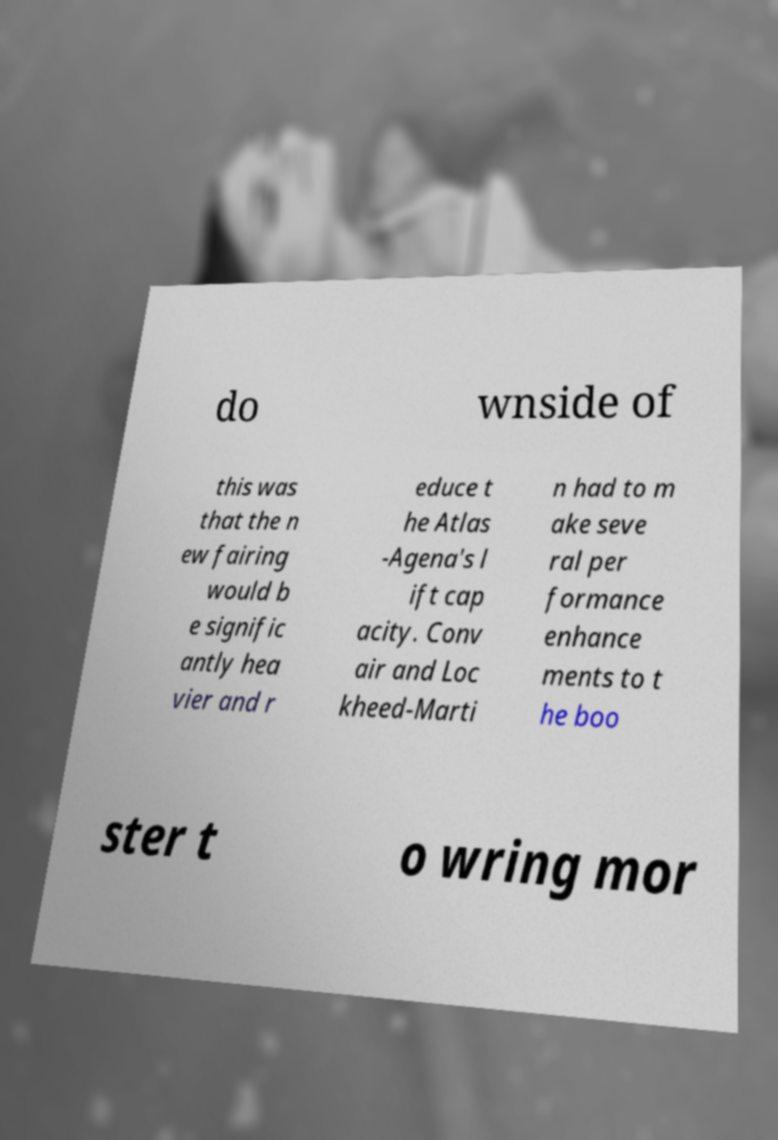I need the written content from this picture converted into text. Can you do that? do wnside of this was that the n ew fairing would b e signific antly hea vier and r educe t he Atlas -Agena's l ift cap acity. Conv air and Loc kheed-Marti n had to m ake seve ral per formance enhance ments to t he boo ster t o wring mor 